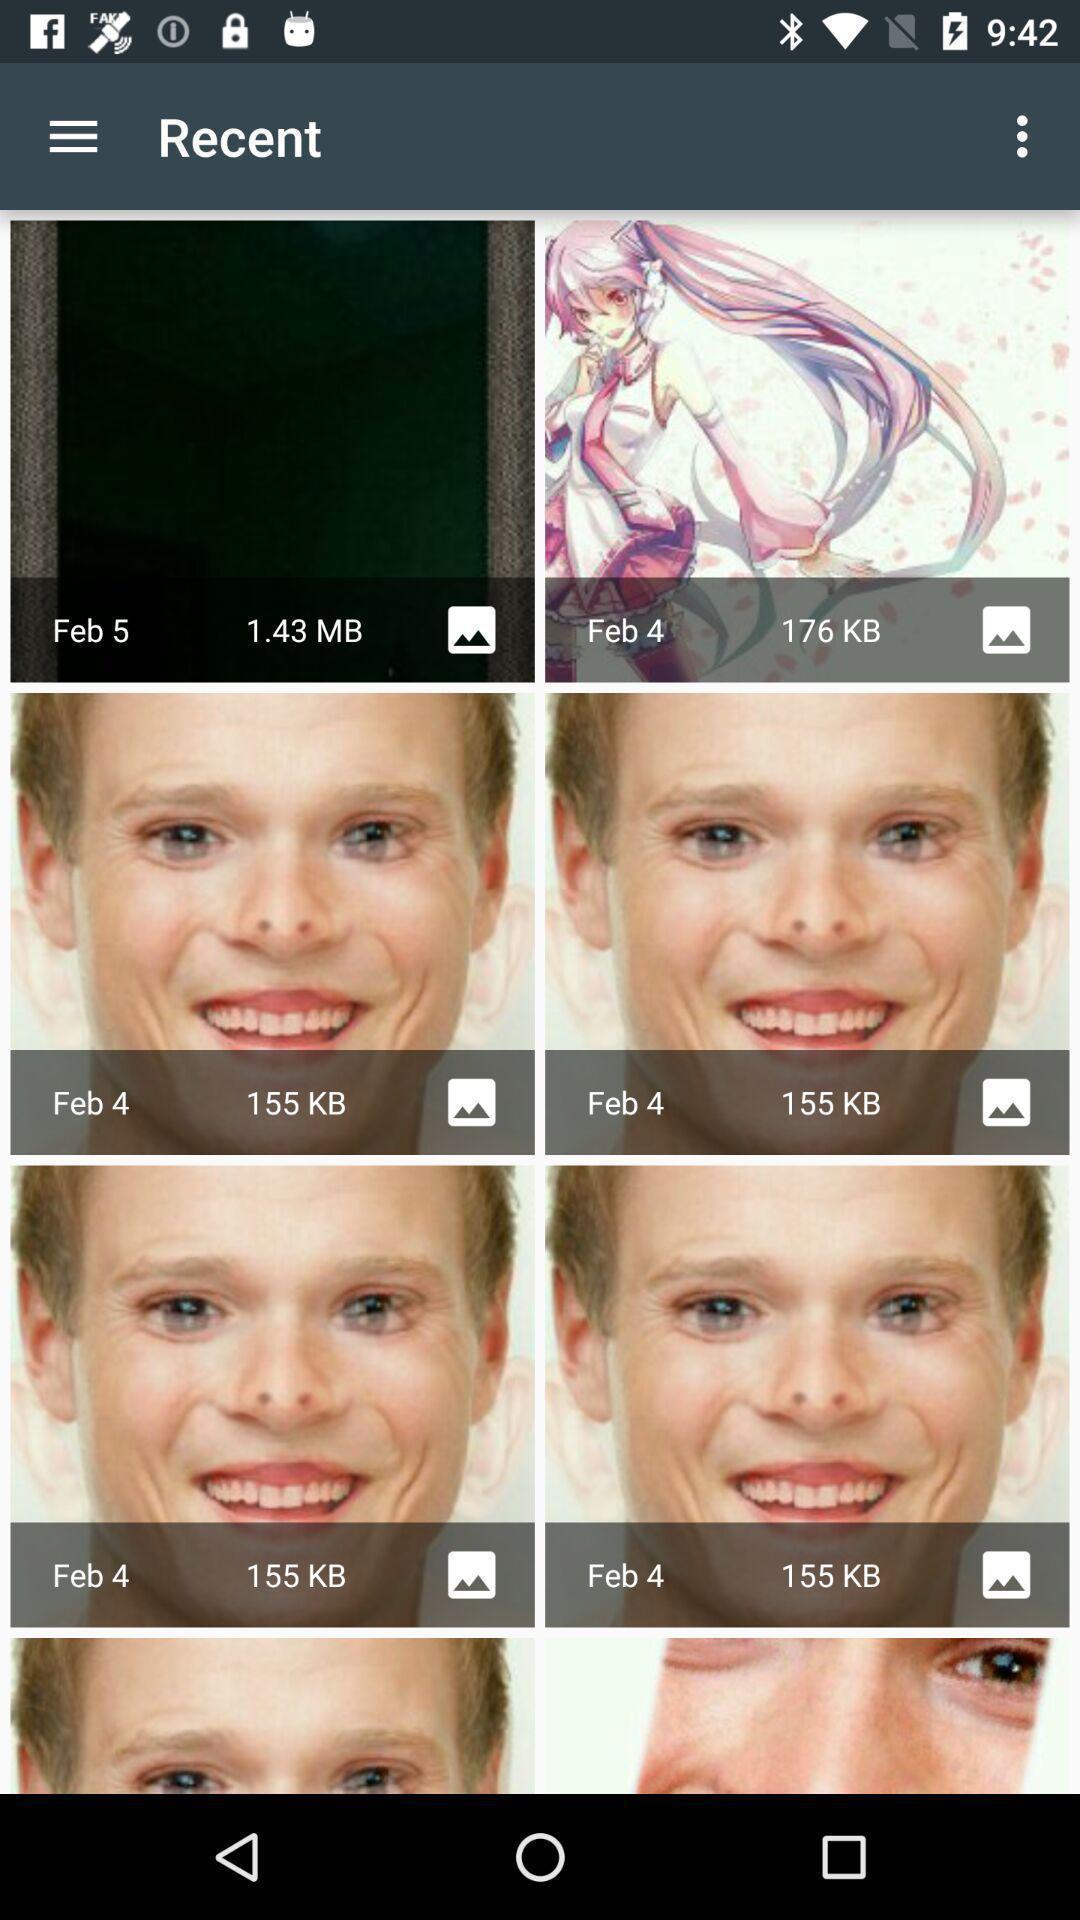What can you discern from this picture? Recent images are displaying in communication app. 